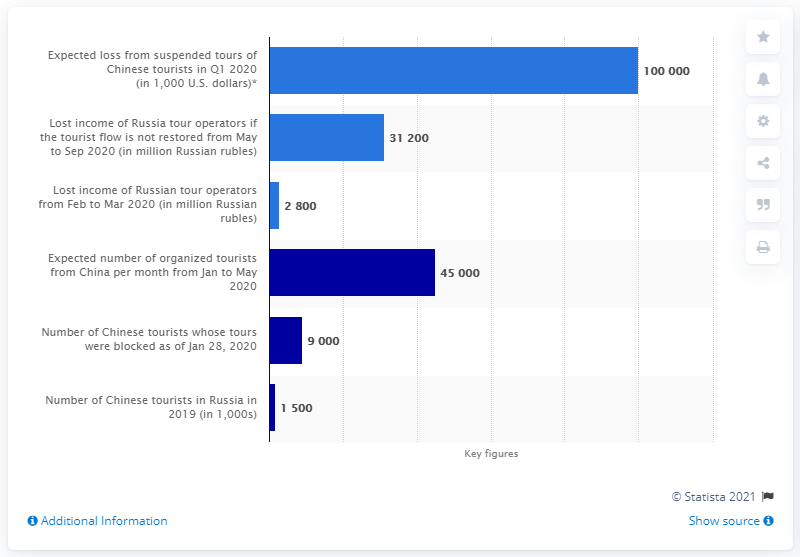List a handful of essential elements in this visual. It is expected that approximately 45,000 tourists will travel to Russia in March 2020. 